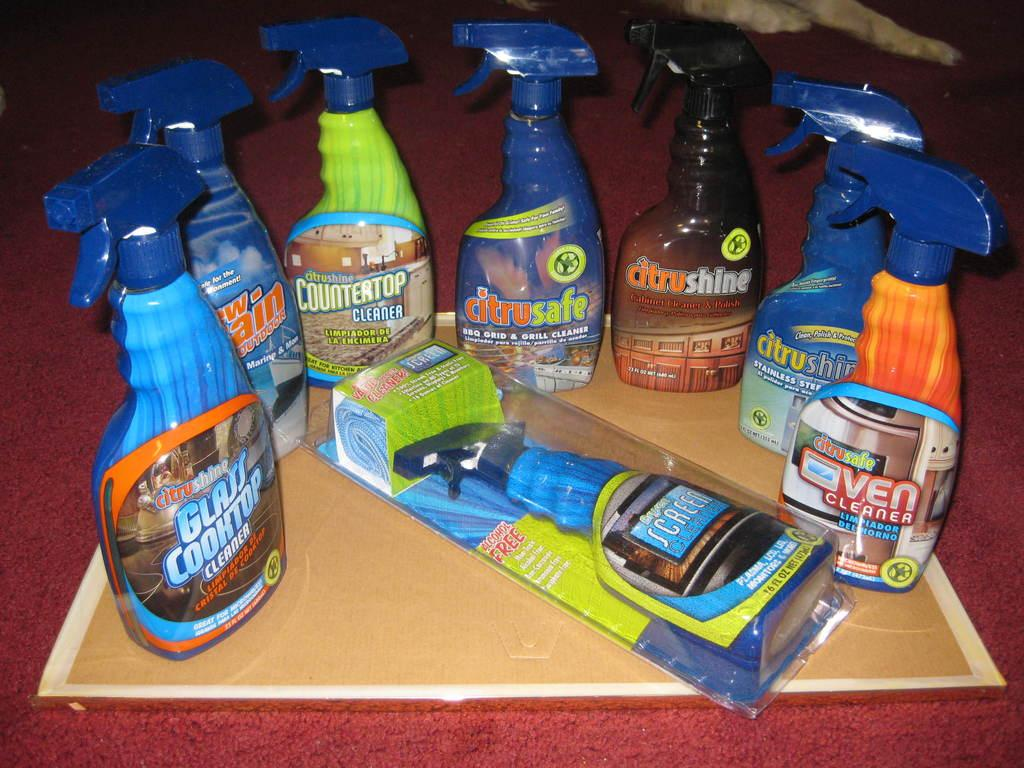<image>
Create a compact narrative representing the image presented. A variety of household cleaners which one is Citru Shine Glass Cooktop Cleaner. 